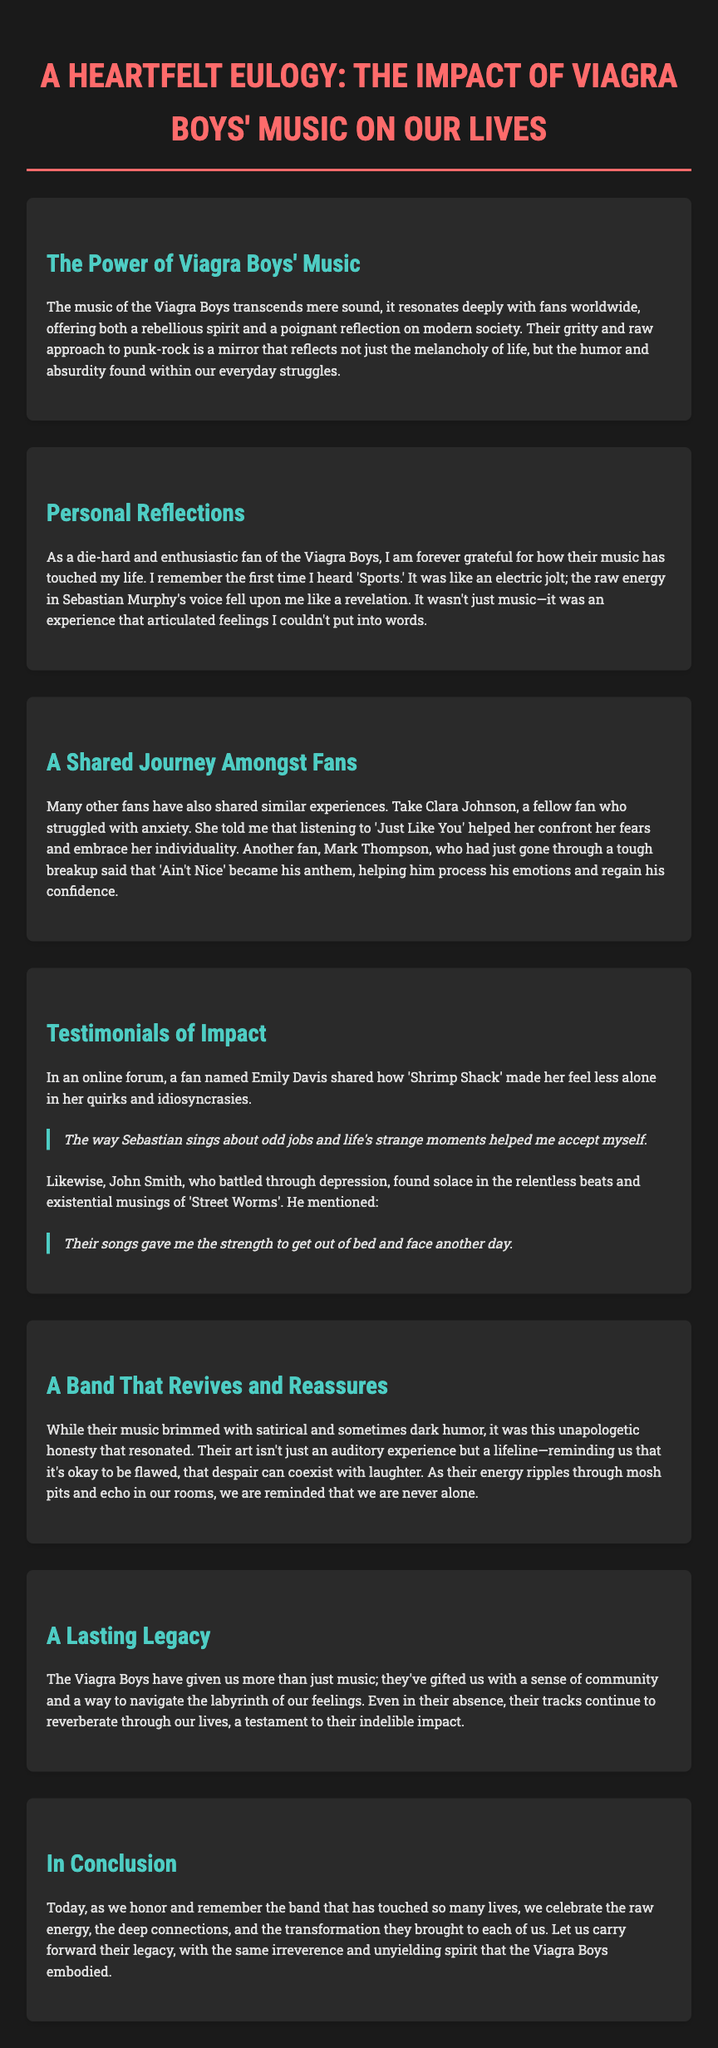what is the title of the document? The title is stated at the top of the document, which is a heartfelt eulogy honoring a band and their impact.
Answer: A Heartfelt Eulogy: The Impact of Viagra Boys' Music on Our Lives who is the lead vocalist of the Viagra Boys mentioned? The document highlights Sebastian Murphy as the lead vocalist whose voice resonates in their music.
Answer: Sebastian Murphy which song helped Clara Johnson confront her fears? The document mentions a specific song that made a significant impact on Clara's life, illustrating her journey with anxiety.
Answer: Just Like You what song became Mark Thompson's anthem after his breakup? The document indicates a specific song that resonated with his emotional state after a tough time.
Answer: Ain't Nice how did Emily Davis describe her experience with 'Shrimp Shack'? The document contains a direct quote about what this song helped her achieve regarding her own identity.
Answer: helped me accept myself which song gave John Smith the strength to face another day? The document references this song as providing solace to John in a challenging period of his life.
Answer: Street Worms what overarching theme do the Viagra Boys' songs convey? The document discusses the themes of humor and absurdity in the context of life's struggles presented in their music.
Answer: unapologetic honesty how many sections are dedicated to the fans' testimonials? The document lays out distinct parts where personal reflections and testimonials are shared about the impact of the music.
Answer: Two sections what type of community did the Viagra Boys create according to the document? The final section reflects on the legacy of the band in terms of community and support among fans.
Answer: sense of community 